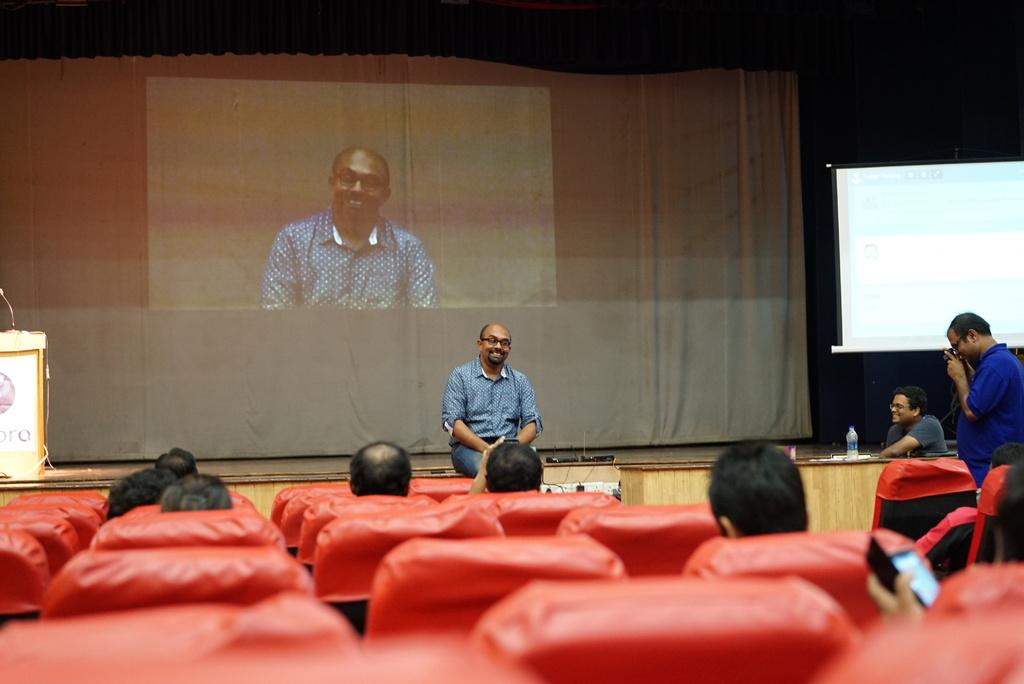What is the man in the image doing? The man is sitting and speaking in the image. What is the man wearing? The man is wearing a shirt and trousers. What can be seen behind the sitting man? There is a projector screen behind the sitting man. Can you describe the other man in the image? There is another man standing on the right side of the image, and he is wearing a blue color shirt. Is the man playing a guitar in the image? There is no guitar present in the image. Can you see the heart rate of the standing man in the image? There is no indication of the heart rate of the standing man in the image. 